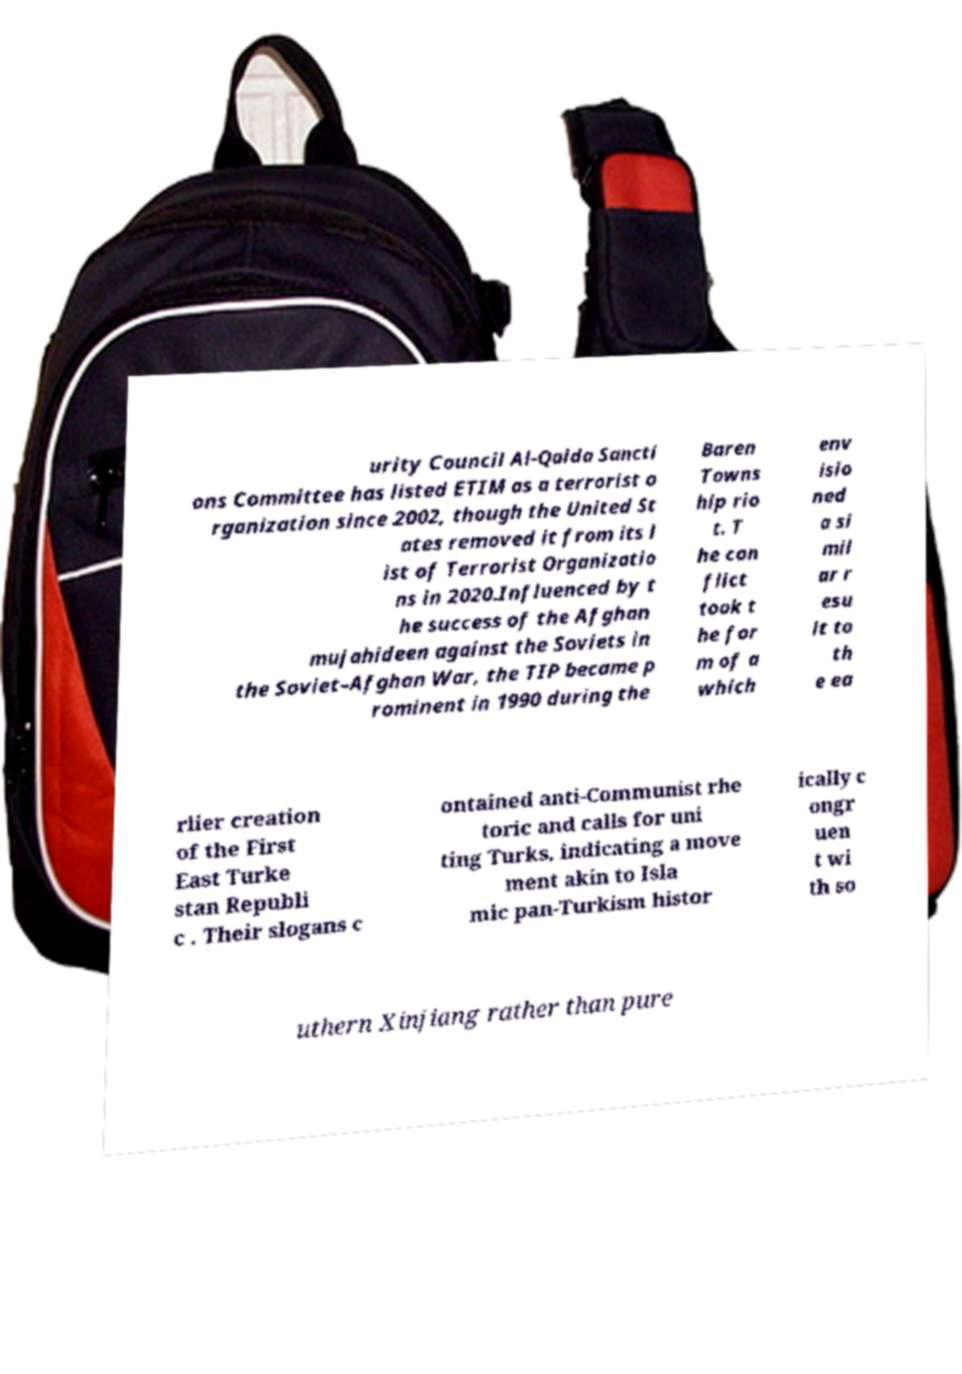Could you extract and type out the text from this image? urity Council Al-Qaida Sancti ons Committee has listed ETIM as a terrorist o rganization since 2002, though the United St ates removed it from its l ist of Terrorist Organizatio ns in 2020.Influenced by t he success of the Afghan mujahideen against the Soviets in the Soviet–Afghan War, the TIP became p rominent in 1990 during the Baren Towns hip rio t. T he con flict took t he for m of a which env isio ned a si mil ar r esu lt to th e ea rlier creation of the First East Turke stan Republi c . Their slogans c ontained anti-Communist rhe toric and calls for uni ting Turks, indicating a move ment akin to Isla mic pan-Turkism histor ically c ongr uen t wi th so uthern Xinjiang rather than pure 